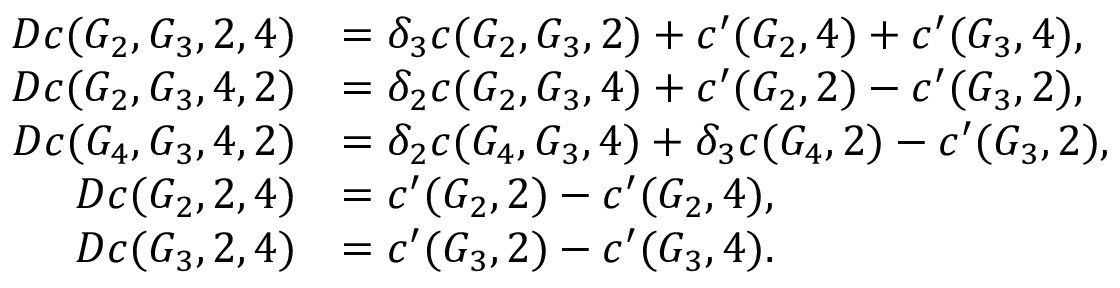Convert formula to latex. <formula><loc_0><loc_0><loc_500><loc_500>\begin{array} { r l } { D c ( G _ { 2 } , G _ { 3 } , 2 , 4 ) } & { = \delta _ { 3 } c ( G _ { 2 } , G _ { 3 } , 2 ) + c ^ { \prime } ( G _ { 2 } , 4 ) + c ^ { \prime } ( G _ { 3 } , 4 ) , } \\ { D c ( G _ { 2 } , G _ { 3 } , 4 , 2 ) } & { = \delta _ { 2 } c ( G _ { 2 } , G _ { 3 } , 4 ) + c ^ { \prime } ( G _ { 2 } , 2 ) - c ^ { \prime } ( G _ { 3 } , 2 ) , } \\ { D c ( G _ { 4 } , G _ { 3 } , 4 , 2 ) } & { = \delta _ { 2 } c ( G _ { 4 } , G _ { 3 } , 4 ) + \delta _ { 3 } c ( G _ { 4 } , 2 ) - c ^ { \prime } ( G _ { 3 } , 2 ) , } \\ { D c ( G _ { 2 } , 2 , 4 ) } & { = c ^ { \prime } ( G _ { 2 } , 2 ) - c ^ { \prime } ( G _ { 2 } , 4 ) , } \\ { D c ( G _ { 3 } , 2 , 4 ) } & { = c ^ { \prime } ( G _ { 3 } , 2 ) - c ^ { \prime } ( G _ { 3 } , 4 ) . } \end{array}</formula> 